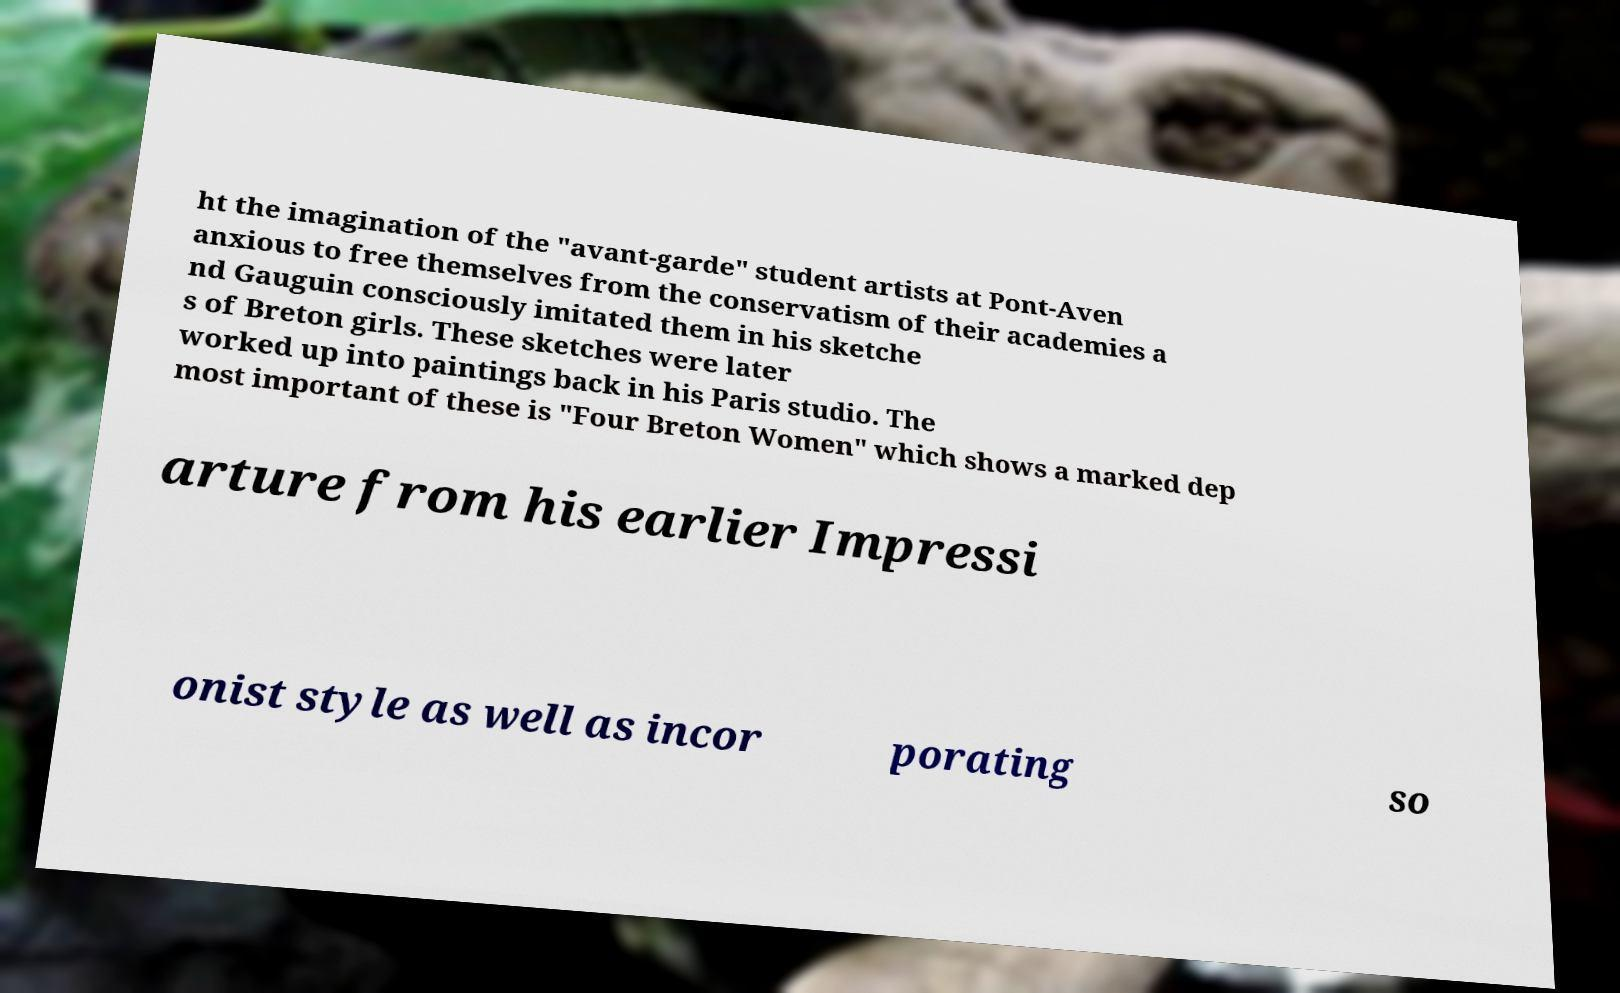I need the written content from this picture converted into text. Can you do that? ht the imagination of the "avant-garde" student artists at Pont-Aven anxious to free themselves from the conservatism of their academies a nd Gauguin consciously imitated them in his sketche s of Breton girls. These sketches were later worked up into paintings back in his Paris studio. The most important of these is "Four Breton Women" which shows a marked dep arture from his earlier Impressi onist style as well as incor porating so 